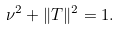<formula> <loc_0><loc_0><loc_500><loc_500>\nu ^ { 2 } + \| T \| ^ { 2 } = 1 .</formula> 